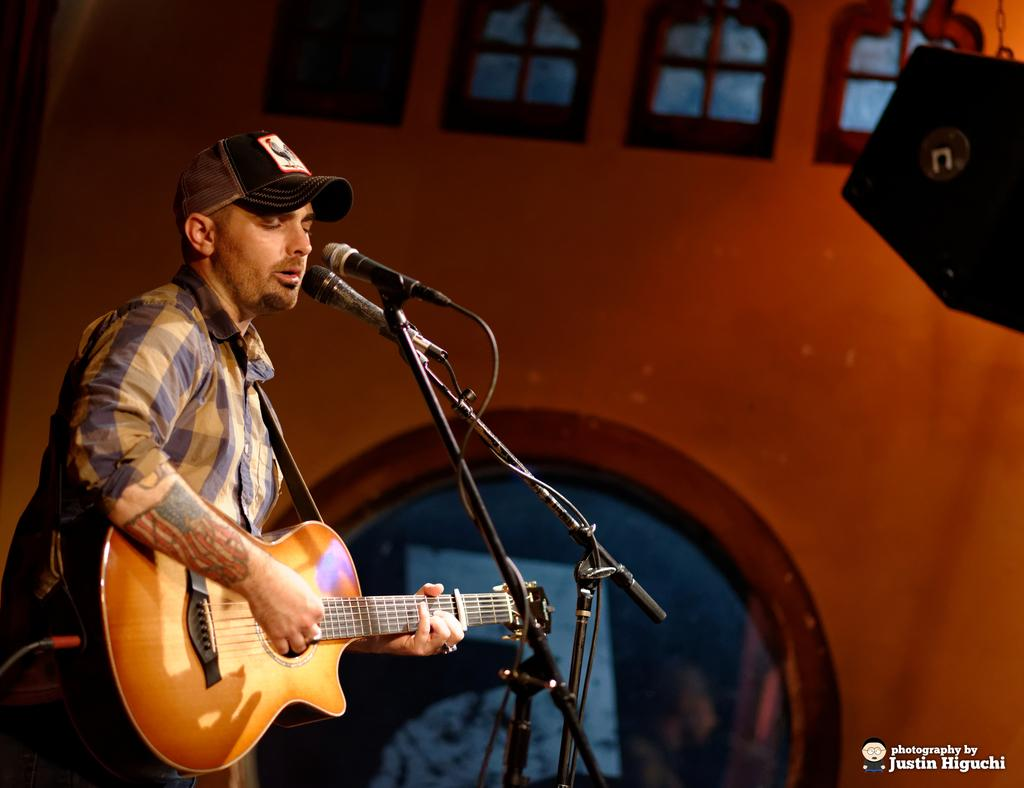What is the person in the image doing? The person is holding a guitar. What accessory is the person wearing? The person is wearing a hat. What object is in front of the person? There is a microphone in front of the person. What can be seen in the background of the image? There is a wall and windows in the background of the image. What type of rabbit can be seen drinking from a cup in the image? There is no rabbit or cup present in the image. What kind of shoe is the person wearing in the image? The provided facts do not mention any shoes worn by the person in the image. 